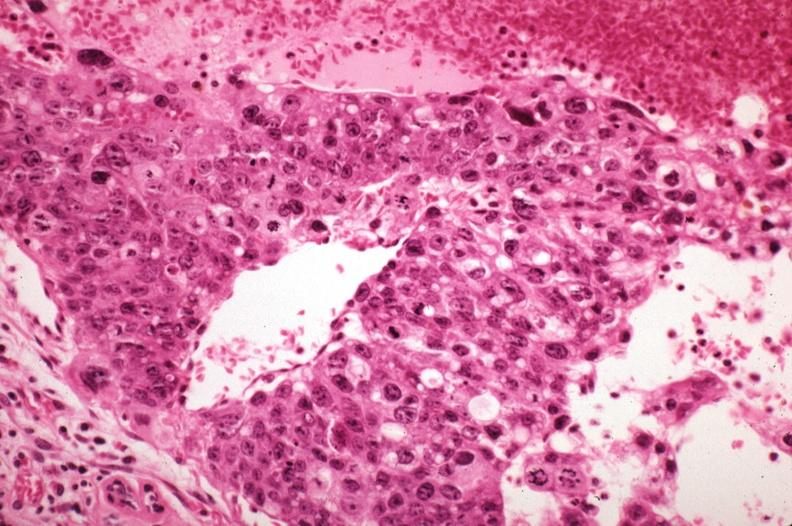what does this image show?
Answer the question using a single word or phrase. Metastatic choriocarcinoma with pleomorphism 